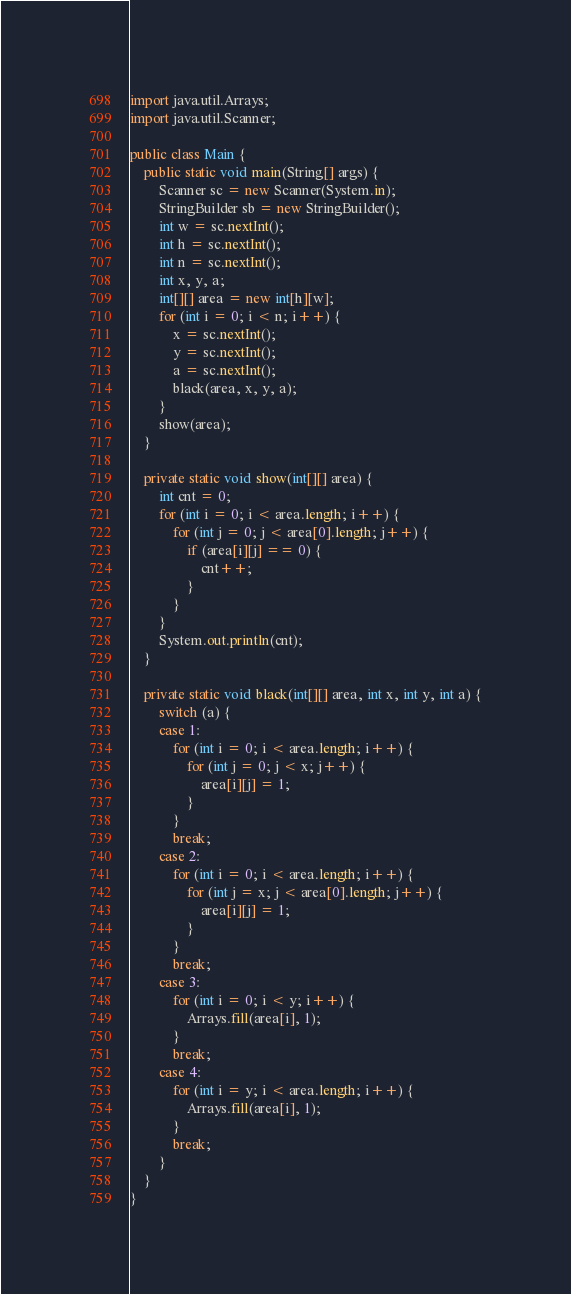<code> <loc_0><loc_0><loc_500><loc_500><_Java_>import java.util.Arrays;
import java.util.Scanner;

public class Main {
	public static void main(String[] args) {
		Scanner sc = new Scanner(System.in);
		StringBuilder sb = new StringBuilder();
		int w = sc.nextInt();
		int h = sc.nextInt();
		int n = sc.nextInt();
		int x, y, a;
		int[][] area = new int[h][w];
		for (int i = 0; i < n; i++) {
			x = sc.nextInt();
			y = sc.nextInt();
			a = sc.nextInt();
			black(area, x, y, a);
		}
		show(area);
	}

	private static void show(int[][] area) {
		int cnt = 0;
		for (int i = 0; i < area.length; i++) {
			for (int j = 0; j < area[0].length; j++) {
				if (area[i][j] == 0) {
					cnt++;
				}
			}
		}
		System.out.println(cnt);
	}

	private static void black(int[][] area, int x, int y, int a) {
		switch (a) {
		case 1:
			for (int i = 0; i < area.length; i++) {
				for (int j = 0; j < x; j++) {
					area[i][j] = 1;
				}
			}
			break;
		case 2:
			for (int i = 0; i < area.length; i++) {
				for (int j = x; j < area[0].length; j++) {
					area[i][j] = 1;
				}
			}
			break;
		case 3:
			for (int i = 0; i < y; i++) {
				Arrays.fill(area[i], 1);
			}
			break;
		case 4:
			for (int i = y; i < area.length; i++) {
				Arrays.fill(area[i], 1);
			}
			break;
		}
	}
}
</code> 